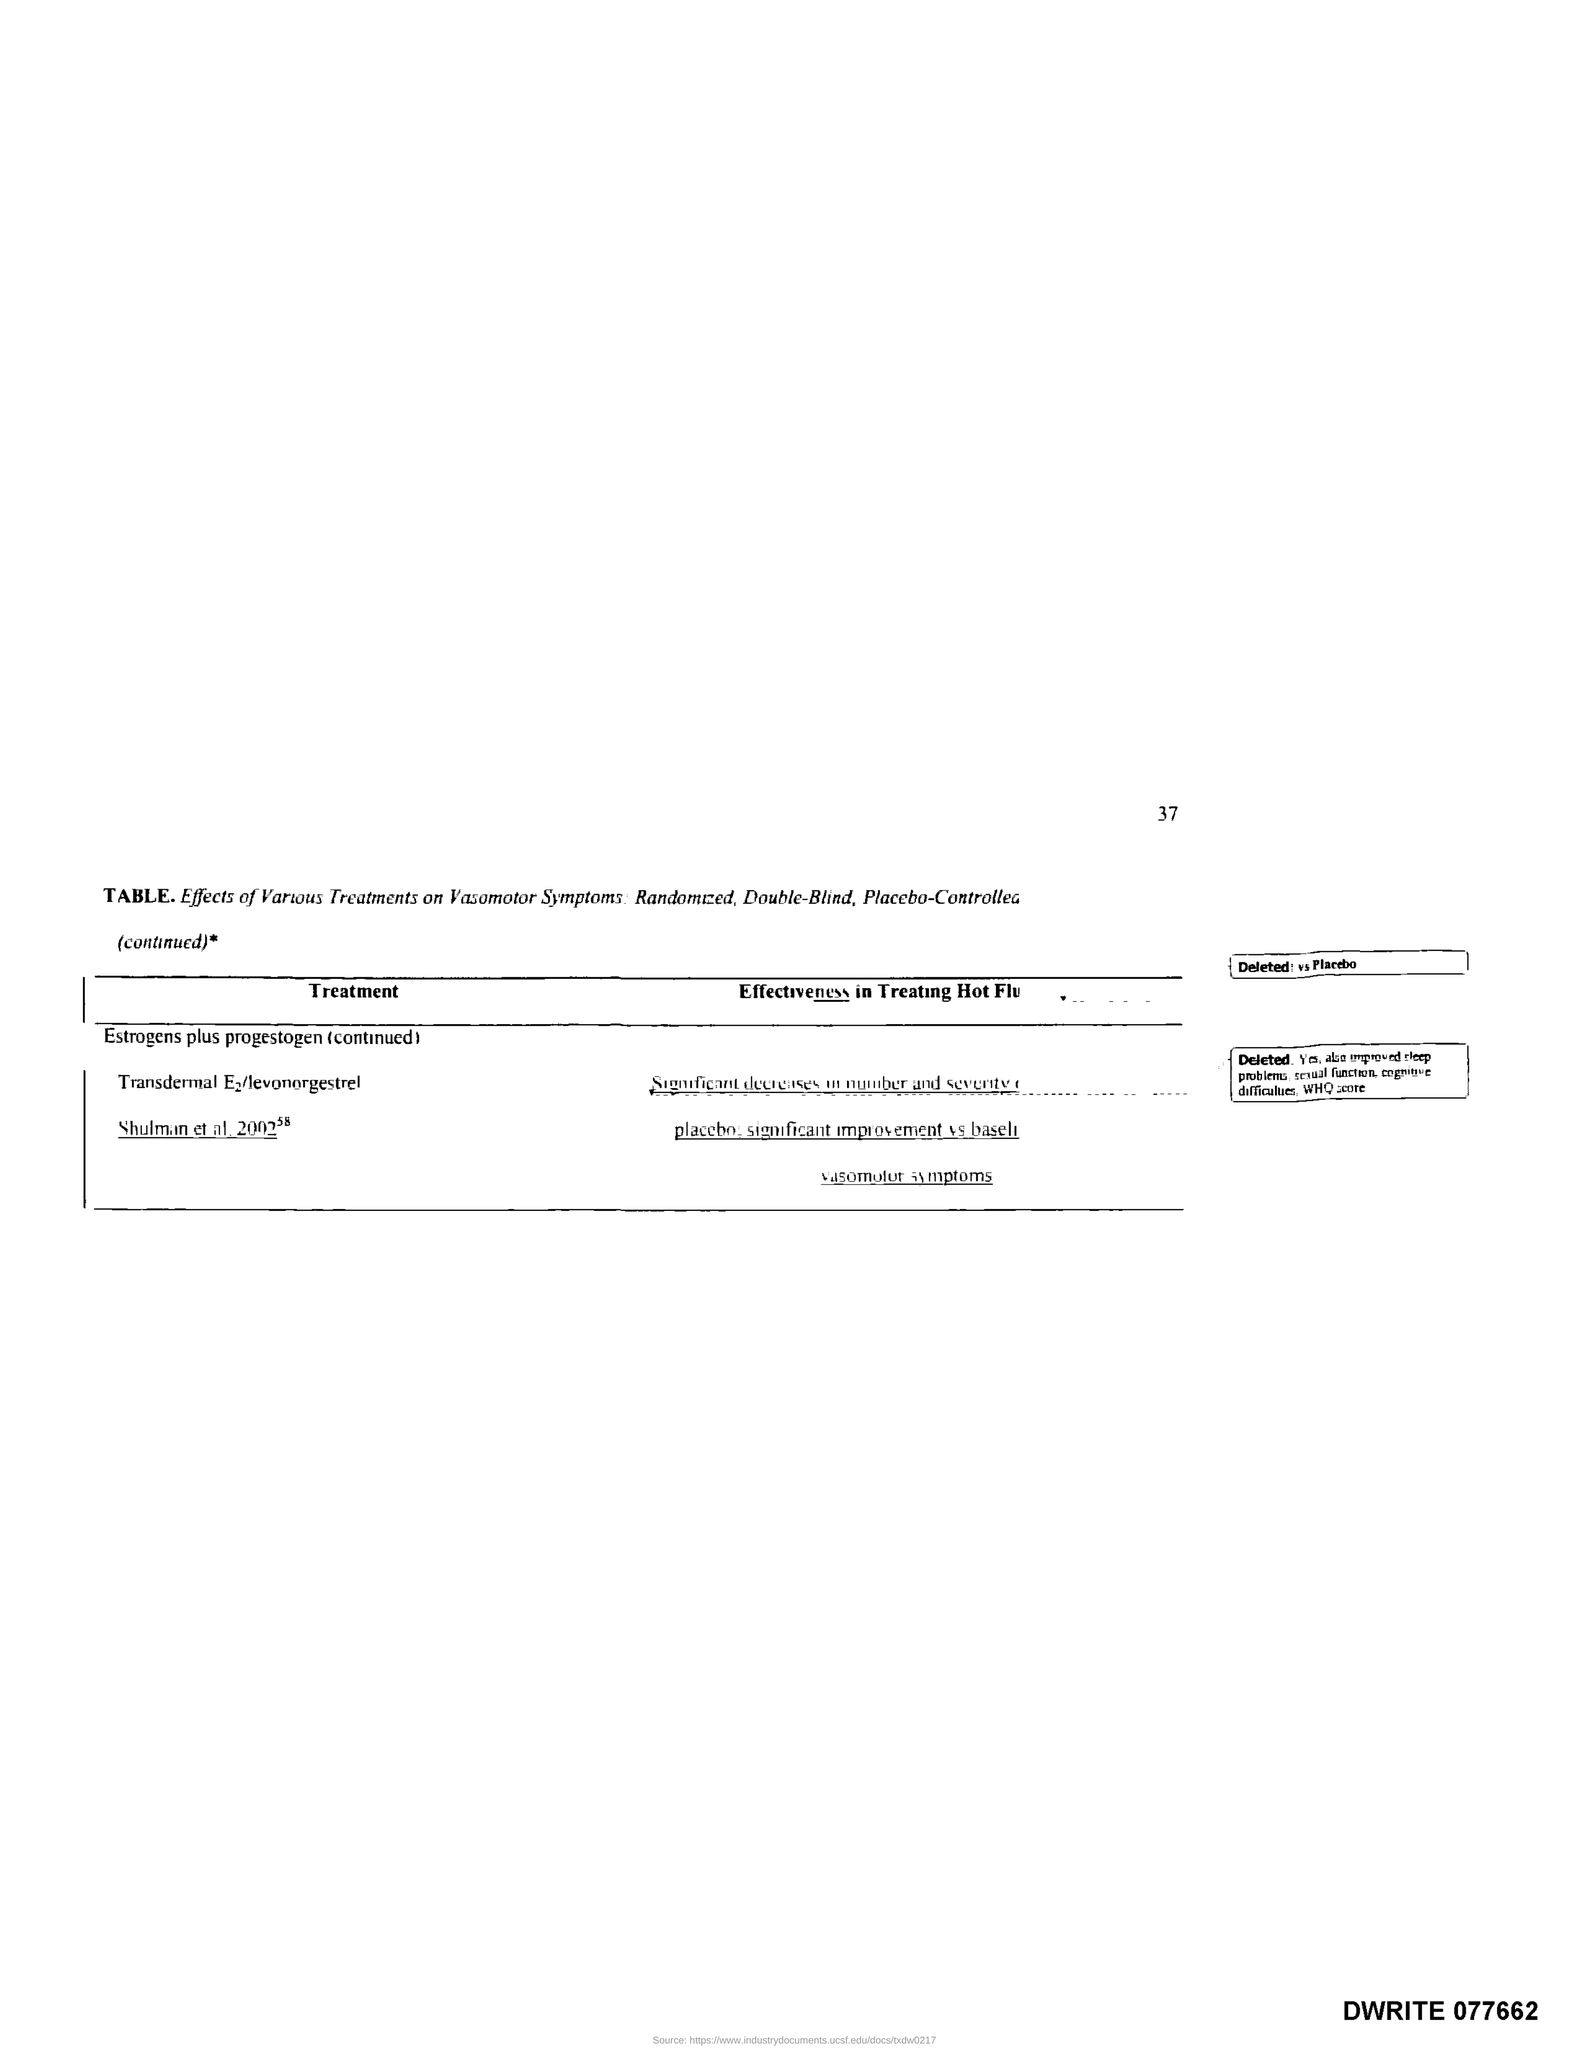What is the Page Number?
Your answer should be very brief. 37. 